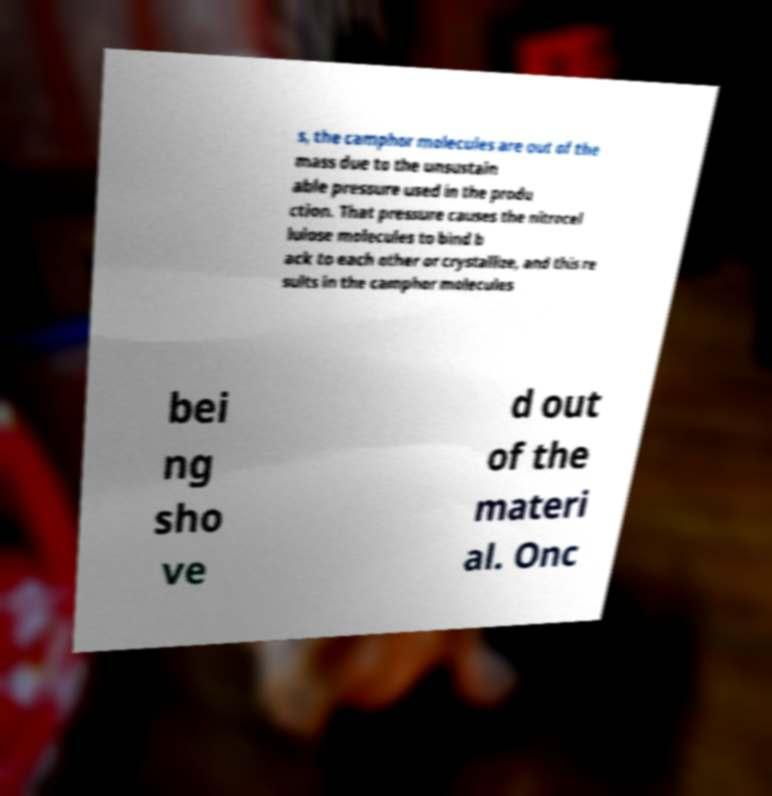What messages or text are displayed in this image? I need them in a readable, typed format. s, the camphor molecules are out of the mass due to the unsustain able pressure used in the produ ction. That pressure causes the nitrocel lulose molecules to bind b ack to each other or crystallize, and this re sults in the camphor molecules bei ng sho ve d out of the materi al. Onc 